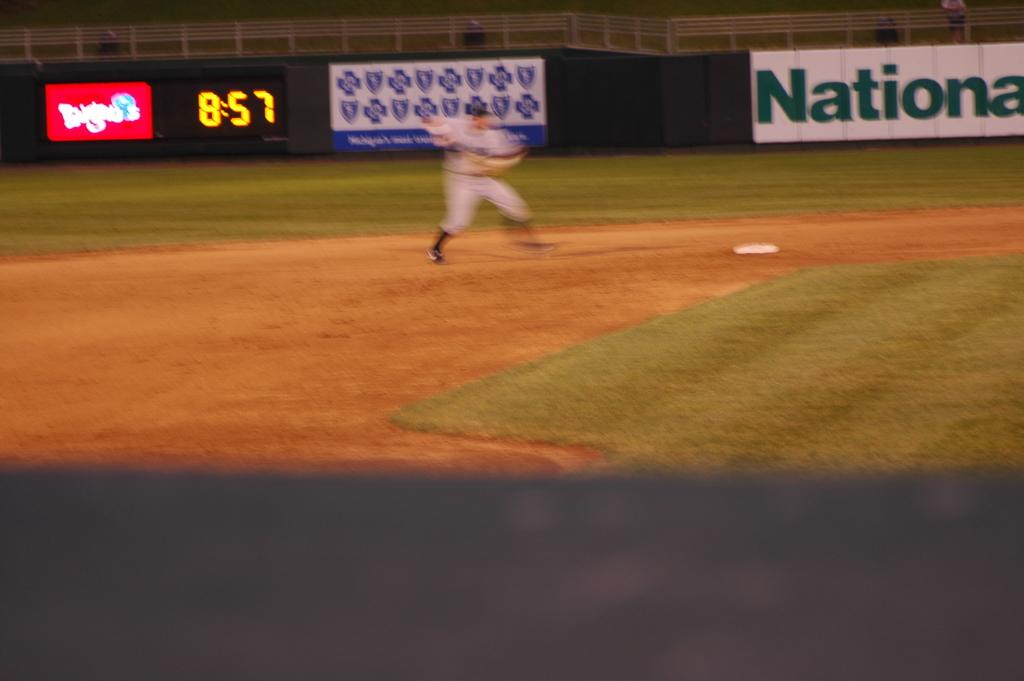<image>
Present a compact description of the photo's key features. Baseball player pitching on a field that has a banner saying NATIONA. 